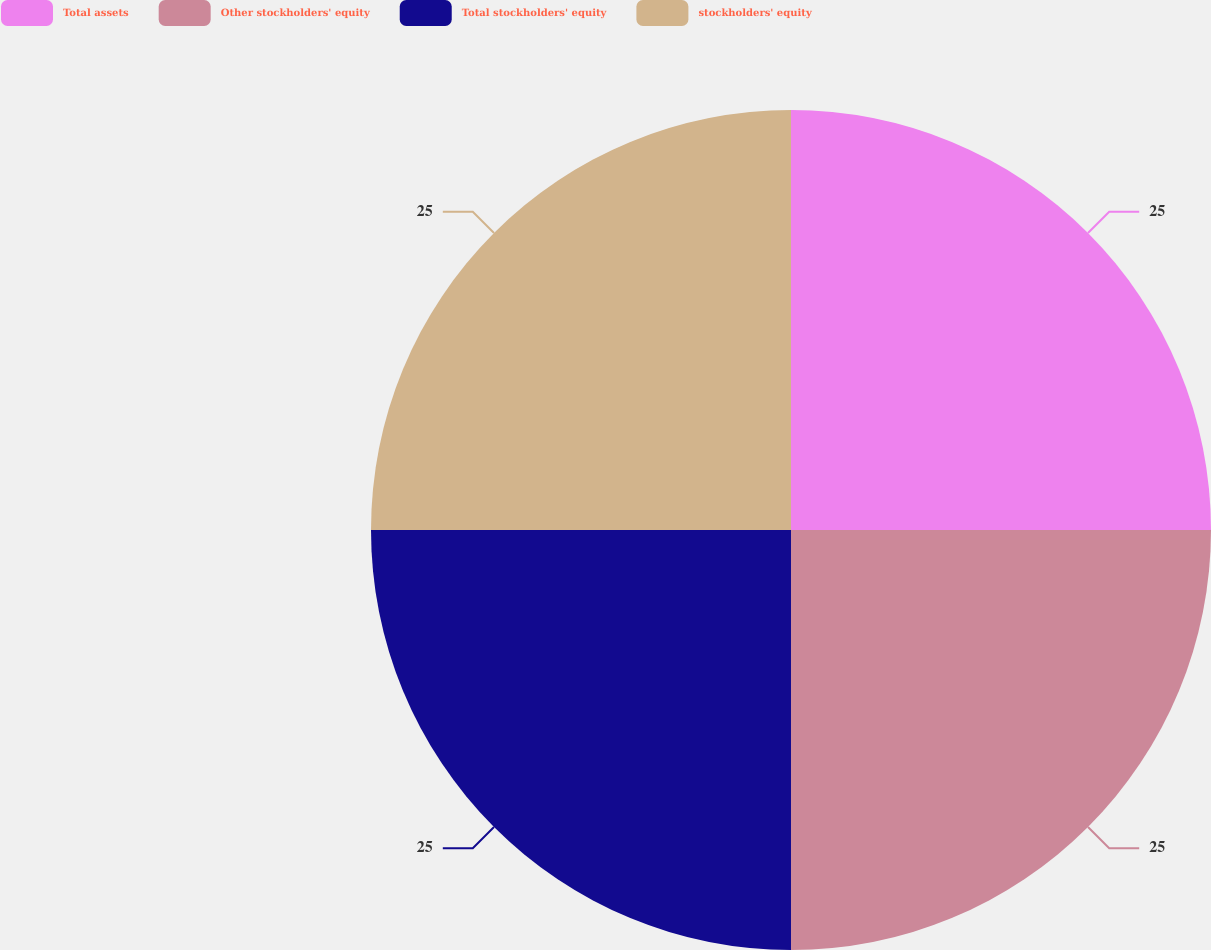<chart> <loc_0><loc_0><loc_500><loc_500><pie_chart><fcel>Total assets<fcel>Other stockholders' equity<fcel>Total stockholders' equity<fcel>stockholders' equity<nl><fcel>25.0%<fcel>25.0%<fcel>25.0%<fcel>25.0%<nl></chart> 